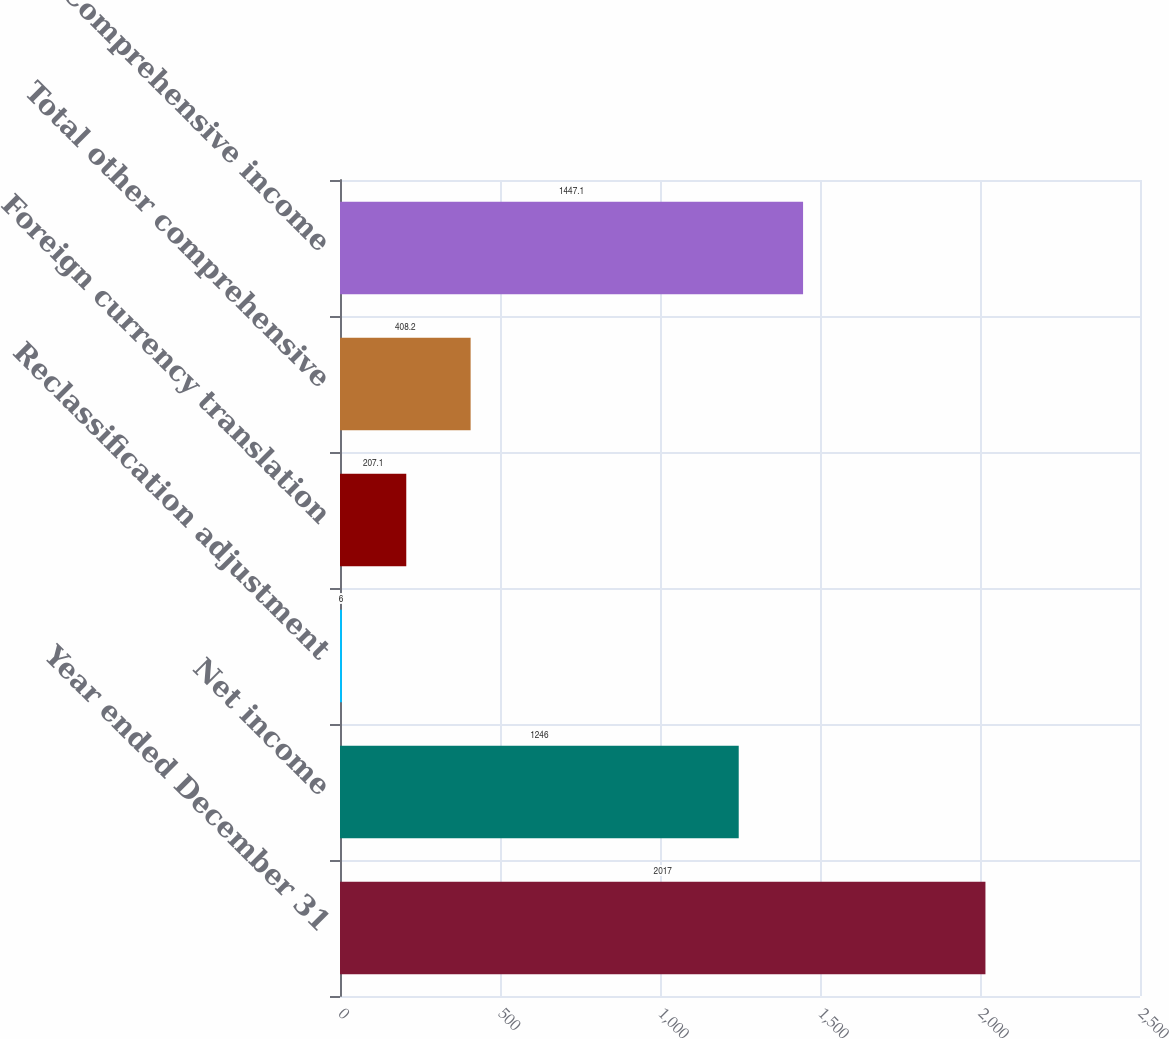Convert chart to OTSL. <chart><loc_0><loc_0><loc_500><loc_500><bar_chart><fcel>Year ended December 31<fcel>Net income<fcel>Reclassification adjustment<fcel>Foreign currency translation<fcel>Total other comprehensive<fcel>Comprehensive income<nl><fcel>2017<fcel>1246<fcel>6<fcel>207.1<fcel>408.2<fcel>1447.1<nl></chart> 